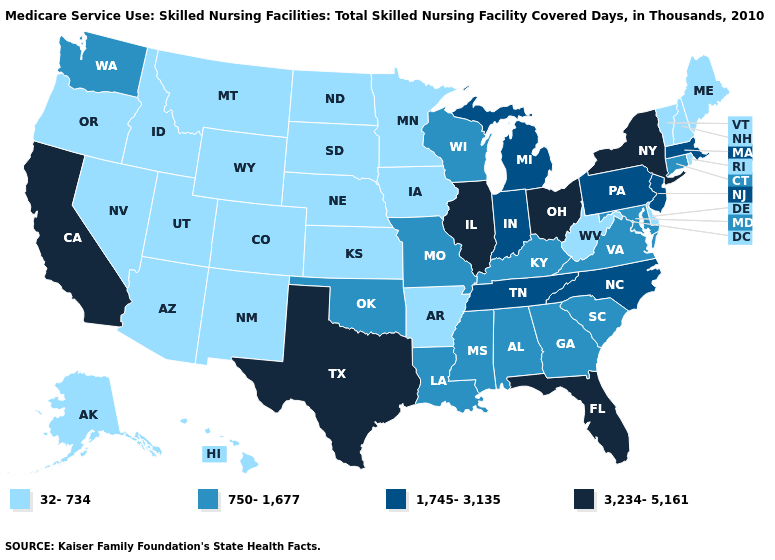What is the value of Kentucky?
Be succinct. 750-1,677. What is the value of Alabama?
Keep it brief. 750-1,677. Name the states that have a value in the range 3,234-5,161?
Give a very brief answer. California, Florida, Illinois, New York, Ohio, Texas. Among the states that border California , which have the lowest value?
Concise answer only. Arizona, Nevada, Oregon. What is the lowest value in states that border Nevada?
Concise answer only. 32-734. Name the states that have a value in the range 3,234-5,161?
Give a very brief answer. California, Florida, Illinois, New York, Ohio, Texas. What is the value of New Hampshire?
Answer briefly. 32-734. Does Oklahoma have the same value as Iowa?
Give a very brief answer. No. Does Wisconsin have a lower value than Idaho?
Write a very short answer. No. Does Iowa have the highest value in the MidWest?
Short answer required. No. What is the value of Wyoming?
Be succinct. 32-734. Does the first symbol in the legend represent the smallest category?
Answer briefly. Yes. Is the legend a continuous bar?
Short answer required. No. Name the states that have a value in the range 32-734?
Be succinct. Alaska, Arizona, Arkansas, Colorado, Delaware, Hawaii, Idaho, Iowa, Kansas, Maine, Minnesota, Montana, Nebraska, Nevada, New Hampshire, New Mexico, North Dakota, Oregon, Rhode Island, South Dakota, Utah, Vermont, West Virginia, Wyoming. Among the states that border Michigan , which have the highest value?
Give a very brief answer. Ohio. 